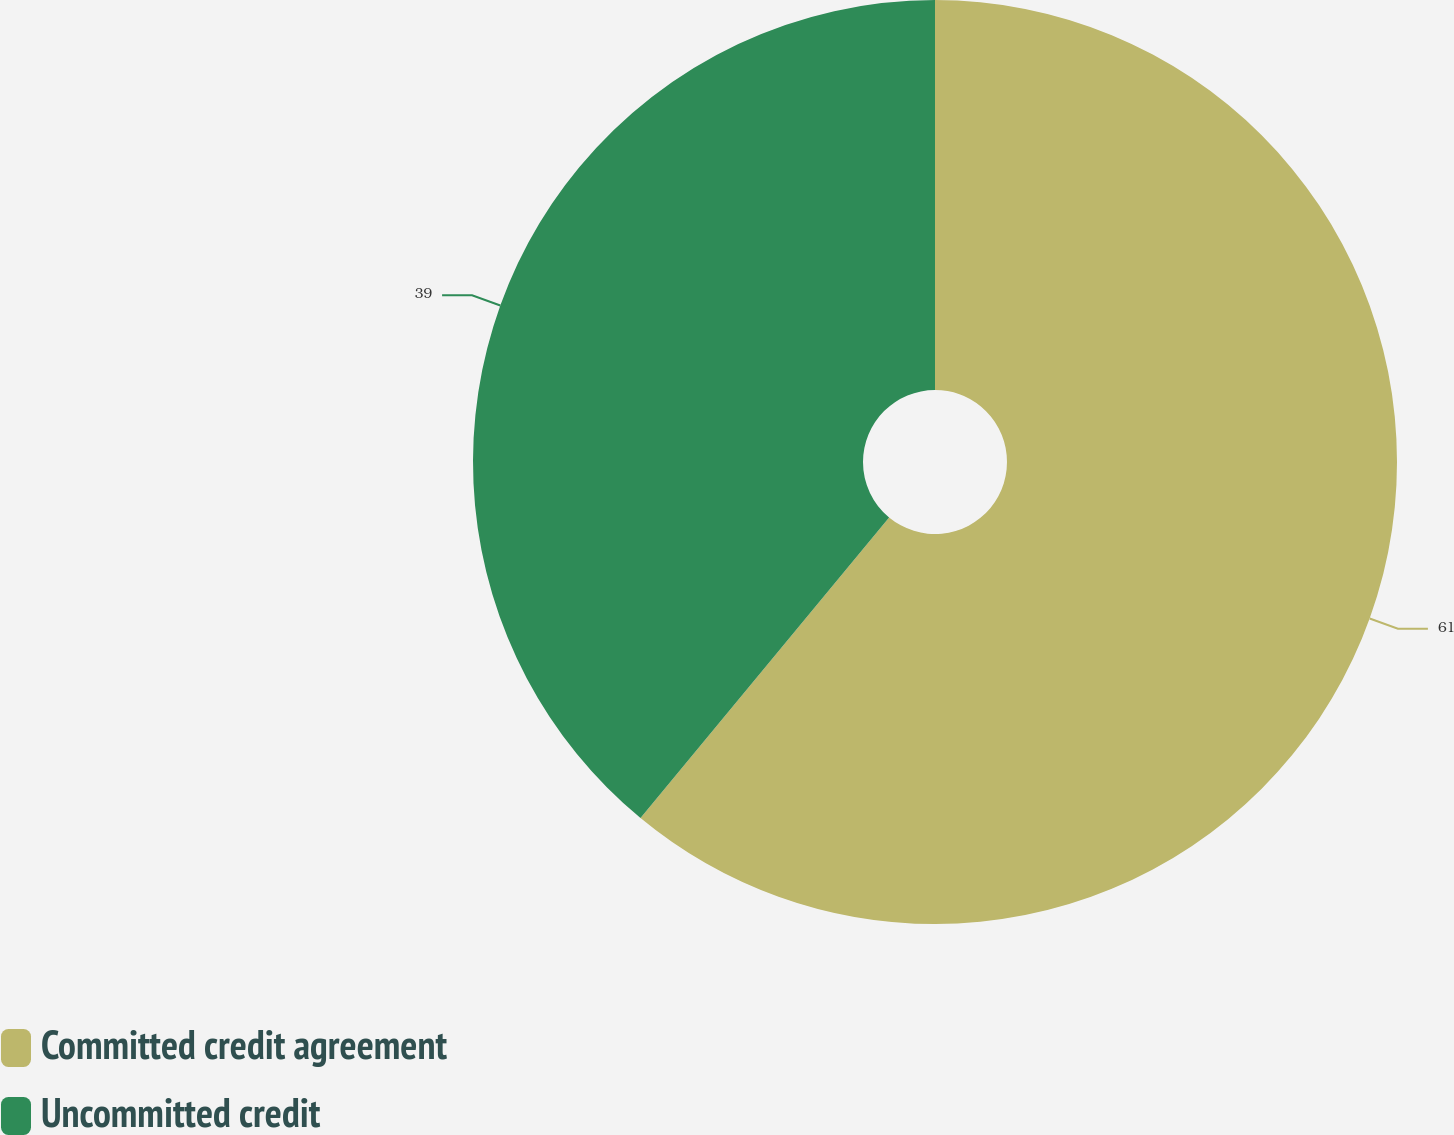<chart> <loc_0><loc_0><loc_500><loc_500><pie_chart><fcel>Committed credit agreement<fcel>Uncommitted credit<nl><fcel>61.0%<fcel>39.0%<nl></chart> 